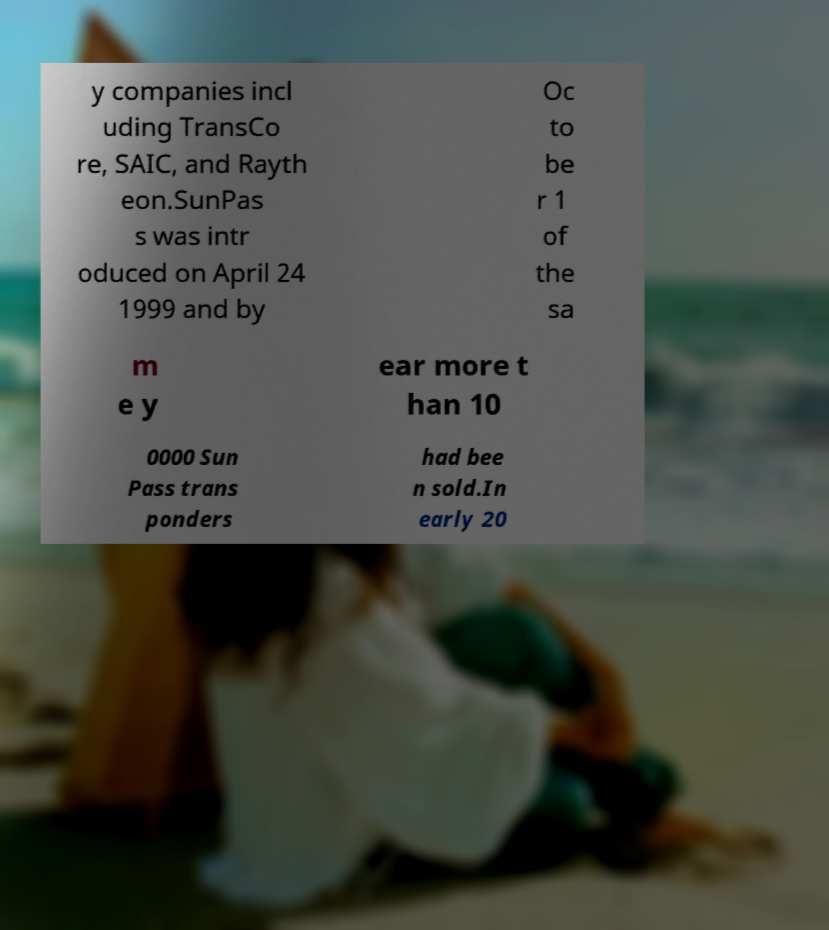Can you accurately transcribe the text from the provided image for me? y companies incl uding TransCo re, SAIC, and Rayth eon.SunPas s was intr oduced on April 24 1999 and by Oc to be r 1 of the sa m e y ear more t han 10 0000 Sun Pass trans ponders had bee n sold.In early 20 